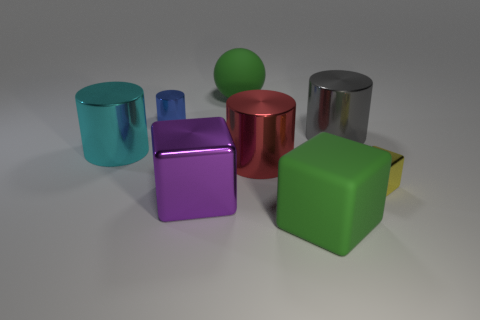Subtract all large purple metal cubes. How many cubes are left? 2 Subtract all red cylinders. How many cylinders are left? 3 Add 2 small blue rubber cubes. How many objects exist? 10 Subtract 2 cubes. How many cubes are left? 1 Subtract all spheres. How many objects are left? 7 Subtract all green rubber cubes. Subtract all blue cylinders. How many objects are left? 6 Add 3 large red things. How many large red things are left? 4 Add 5 green spheres. How many green spheres exist? 6 Subtract 1 yellow blocks. How many objects are left? 7 Subtract all yellow cylinders. Subtract all gray cubes. How many cylinders are left? 4 